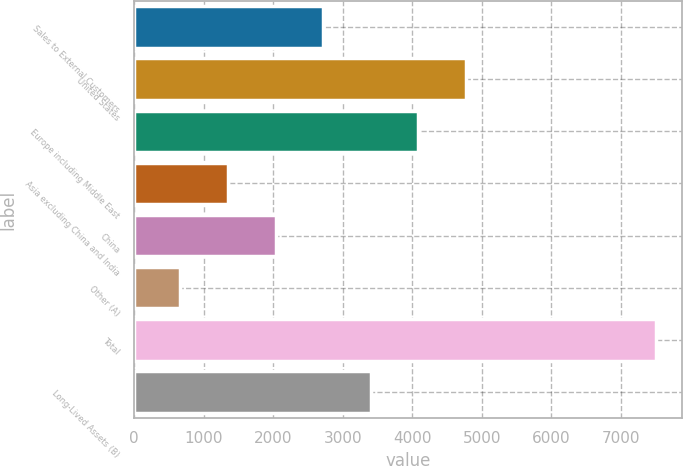<chart> <loc_0><loc_0><loc_500><loc_500><bar_chart><fcel>Sales to External Customers<fcel>United States<fcel>Europe including Middle East<fcel>Asia excluding China and India<fcel>China<fcel>Other (A)<fcel>Total<fcel>Long-Lived Assets (B)<nl><fcel>2715.7<fcel>4767.7<fcel>4083.7<fcel>1347.7<fcel>2031.7<fcel>663.7<fcel>7503.7<fcel>3399.7<nl></chart> 